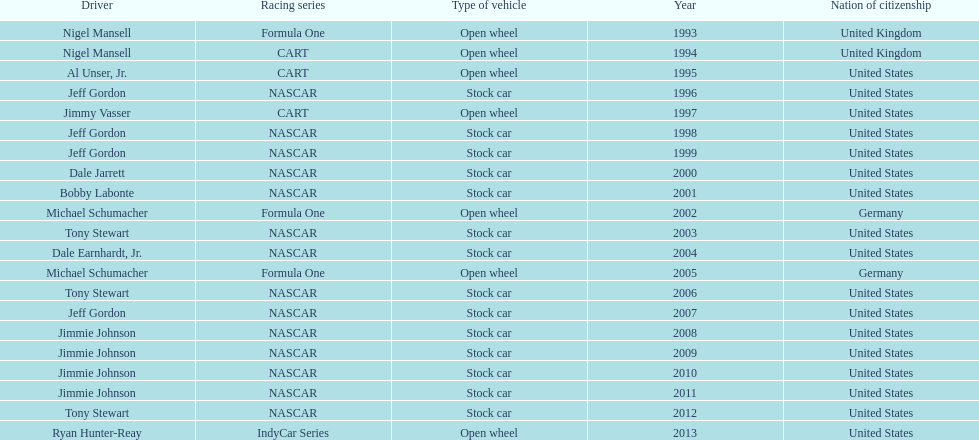Which chauffeur accomplished four continuous wins? Jimmie Johnson. 